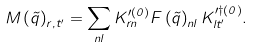Convert formula to latex. <formula><loc_0><loc_0><loc_500><loc_500>M \left ( \vec { q } \right ) _ { r , t ^ { \prime } } = \sum _ { n l } K ^ { \prime ( 0 ) } _ { r n } F \left ( \vec { q } \right ) _ { n l } K ^ { \prime \dagger ( 0 ) } _ { l t ^ { \prime } } .</formula> 